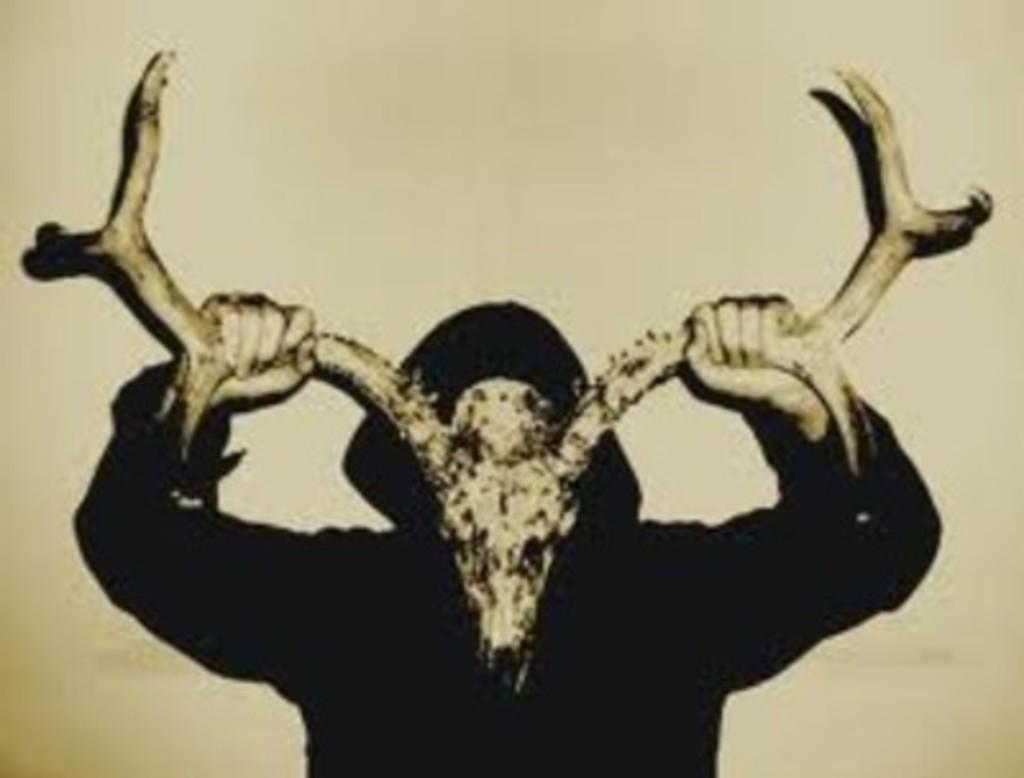What is the main subject of the picture? The main subject of the picture is a human. What is the human holding in the image? The human is holding a deer head mount. Can you describe the background of the image? The background of the image is plain. What type of writer can be seen in the image? There is no writer present in the image; it features a human holding a deer head mount. What type of harmony is depicted in the image? There is no harmony depicted in the image; it features a human holding a deer head mount against a plain background. 